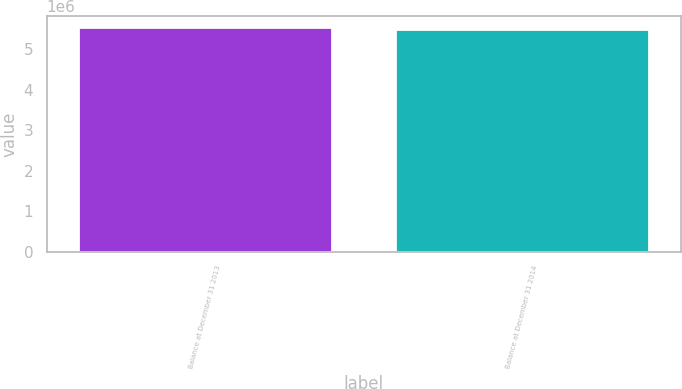Convert chart to OTSL. <chart><loc_0><loc_0><loc_500><loc_500><bar_chart><fcel>Balance at December 31 2013<fcel>Balance at December 31 2014<nl><fcel>5.53394e+06<fcel>5.49753e+06<nl></chart> 